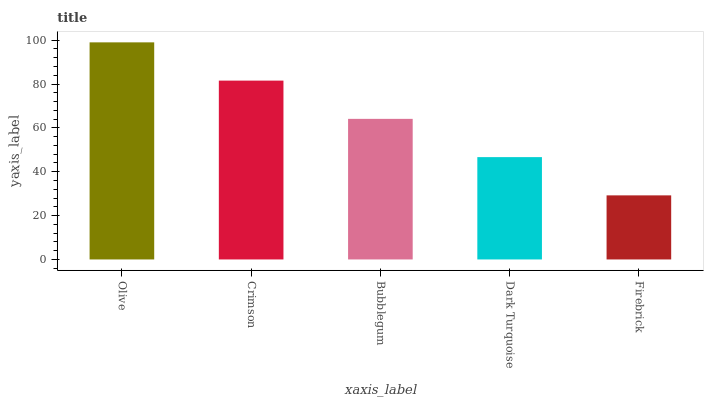Is Crimson the minimum?
Answer yes or no. No. Is Crimson the maximum?
Answer yes or no. No. Is Olive greater than Crimson?
Answer yes or no. Yes. Is Crimson less than Olive?
Answer yes or no. Yes. Is Crimson greater than Olive?
Answer yes or no. No. Is Olive less than Crimson?
Answer yes or no. No. Is Bubblegum the high median?
Answer yes or no. Yes. Is Bubblegum the low median?
Answer yes or no. Yes. Is Crimson the high median?
Answer yes or no. No. Is Firebrick the low median?
Answer yes or no. No. 